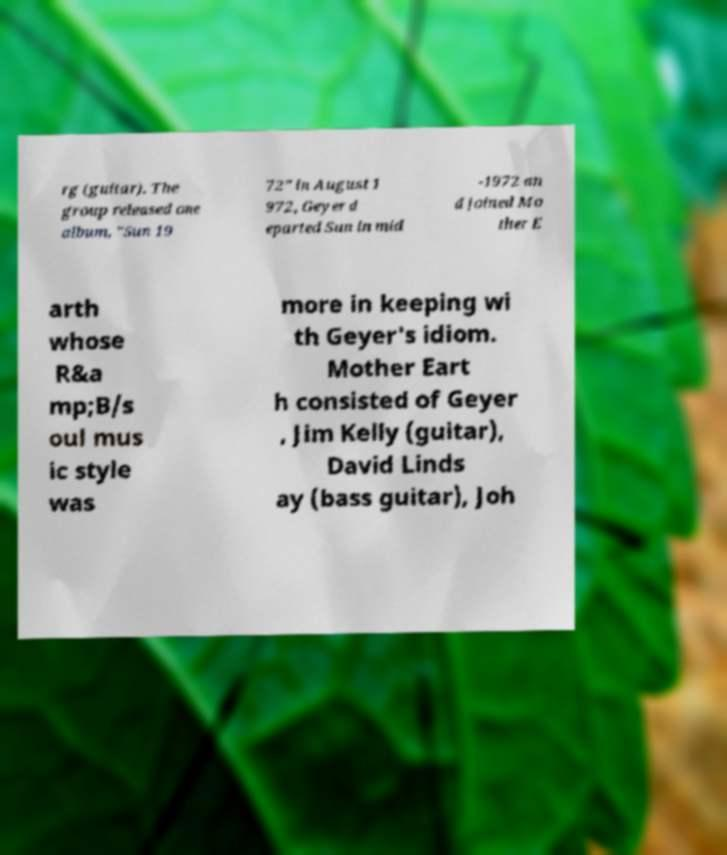There's text embedded in this image that I need extracted. Can you transcribe it verbatim? rg (guitar). The group released one album, "Sun 19 72" in August 1 972, Geyer d eparted Sun in mid -1972 an d joined Mo ther E arth whose R&a mp;B/s oul mus ic style was more in keeping wi th Geyer's idiom. Mother Eart h consisted of Geyer , Jim Kelly (guitar), David Linds ay (bass guitar), Joh 